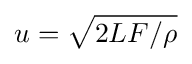Convert formula to latex. <formula><loc_0><loc_0><loc_500><loc_500>u = \sqrt { 2 L F / \rho }</formula> 